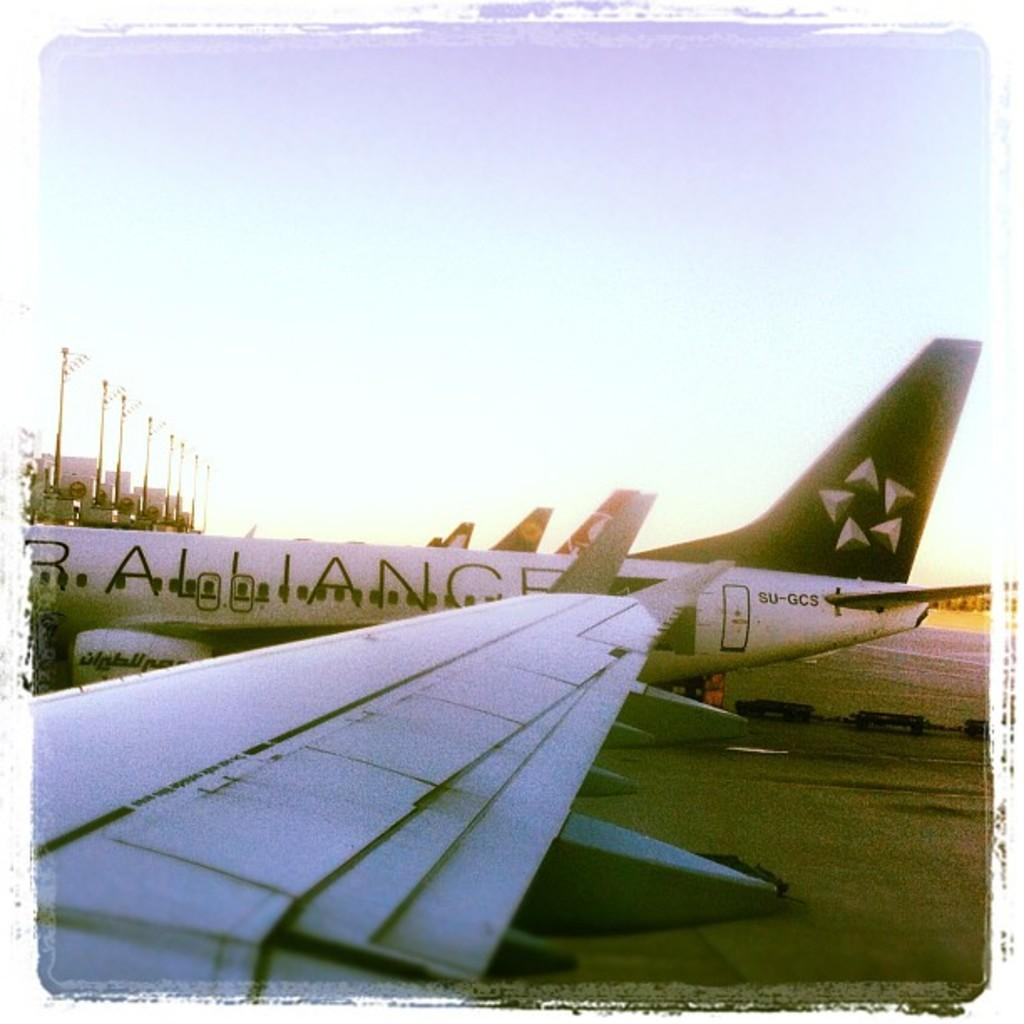What is the main subject of the image? The main subject of the image is airplanes. What color are the airplanes in the image? The airplanes are white in color. What can be seen in the background of the image? The sky and poles are visible in the background of the image. What type of loaf can be seen in the image? There is no loaf present in the image; it features airplanes and background elements. 